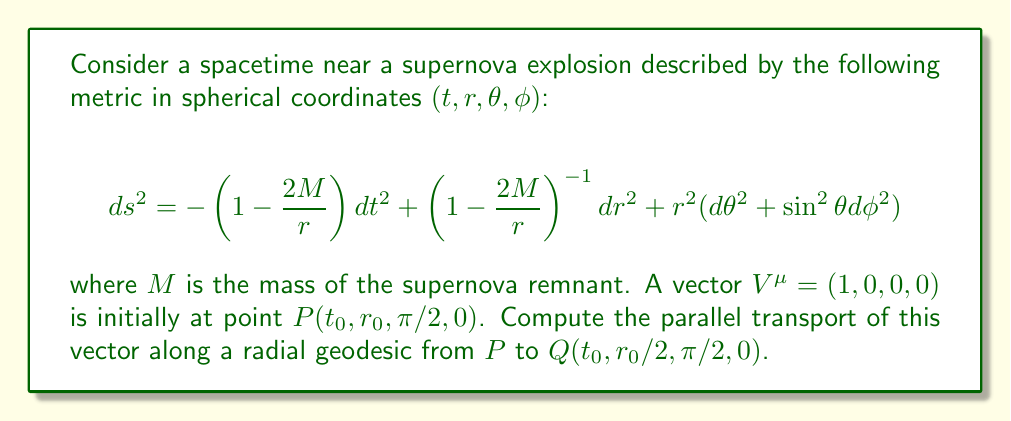Provide a solution to this math problem. To solve this problem, we'll follow these steps:

1) The parallel transport equation is given by:

   $$ \frac{dV^\mu}{d\lambda} + \Gamma^\mu_{\nu\sigma}V^\nu\frac{dx^\sigma}{d\lambda} = 0 $$

   where $\lambda$ is an affine parameter along the geodesic.

2) For a radial geodesic, only $r$ changes. So, $\frac{dx^\sigma}{d\lambda} = (0,\frac{dr}{d\lambda},0,0)$

3) We need to calculate the relevant Christoffel symbols. For this metric, the non-zero symbols we need are:

   $$ \Gamma^t_{tr} = \Gamma^t_{rt} = \frac{M}{r(r-2M)} $$
   $$ \Gamma^r_{tt} = \frac{M(r-2M)}{r^3} $$

4) Substituting into the parallel transport equation:

   $$ \frac{dV^t}{d\lambda} + \Gamma^t_{tr}V^t\frac{dr}{d\lambda} = 0 $$

5) This simplifies to:

   $$ \frac{dV^t}{d\lambda} + \frac{M}{r(r-2M)}V^t\frac{dr}{d\lambda} = 0 $$

6) We can separate variables and integrate:

   $$ \int\frac{dV^t}{V^t} = -\int\frac{M}{r(r-2M)}dr $$

7) Integrating from $r_0$ to $r_0/2$:

   $$ \ln\left(\frac{V^t_f}{V^t_i}\right) = \ln\left(\frac{r_0-2M}{r_0/2-2M}\right)^{1/2} $$

8) Therefore:

   $$ V^t_f = V^t_i\sqrt{\frac{r_0-2M}{r_0/2-2M}} $$

9) Since $V^t_i = 1$, our final result is:

   $$ V^t_f = \sqrt{\frac{r_0-2M}{r_0/2-2M}} $$

The other components remain zero.
Answer: $V^\mu_f = (\sqrt{\frac{r_0-2M}{r_0/2-2M}},0,0,0)$ 